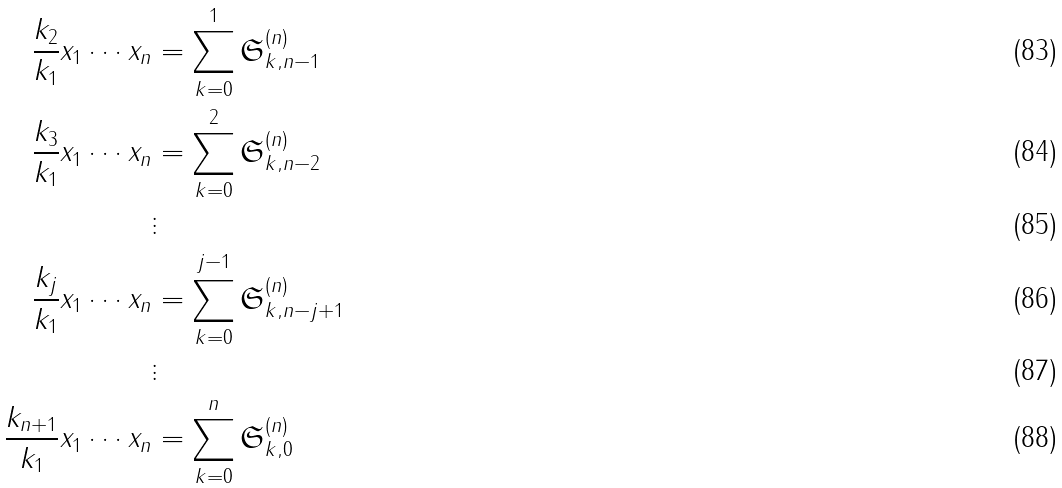Convert formula to latex. <formula><loc_0><loc_0><loc_500><loc_500>\frac { k _ { 2 } } { k _ { 1 } } x _ { 1 } \cdots x _ { n } & = \sum _ { k = 0 } ^ { 1 } \mathfrak { S } ^ { ( n ) } _ { k , n - 1 } \\ \frac { k _ { 3 } } { k _ { 1 } } x _ { 1 } \cdots x _ { n } & = \sum _ { k = 0 } ^ { 2 } \mathfrak { S } ^ { ( n ) } _ { k , n - 2 } \\ & \vdots \\ \frac { k _ { j } } { k _ { 1 } } x _ { 1 } \cdots x _ { n } & = \sum _ { k = 0 } ^ { j - 1 } \mathfrak { S } ^ { ( n ) } _ { k , n - j + 1 } \\ & \vdots \\ \frac { k _ { n + 1 } } { k _ { 1 } } x _ { 1 } \cdots x _ { n } & = \sum _ { k = 0 } ^ { n } \mathfrak { S } ^ { ( n ) } _ { k , 0 }</formula> 